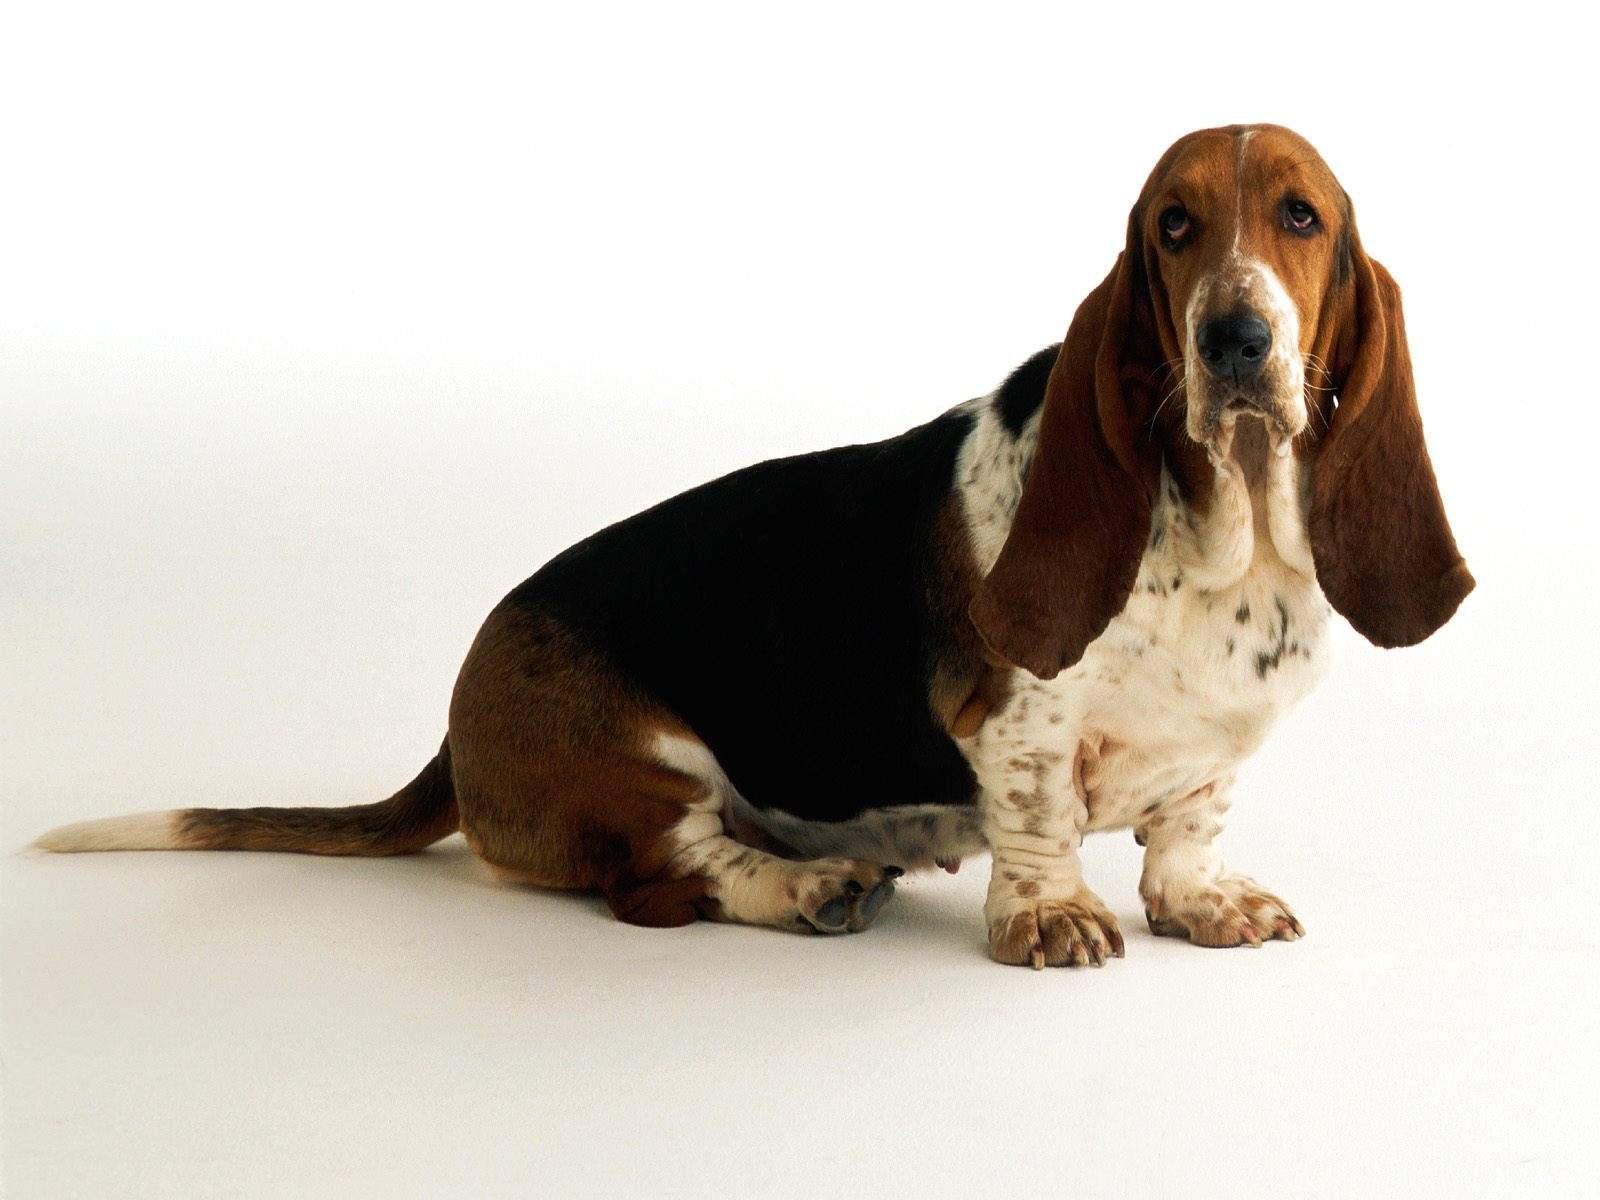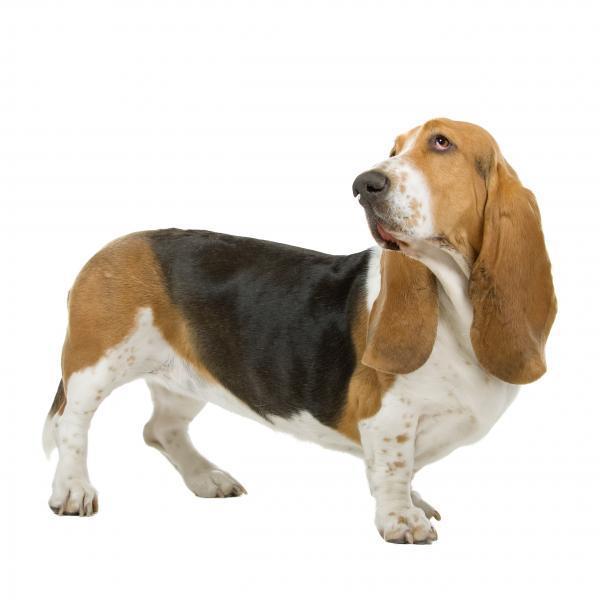The first image is the image on the left, the second image is the image on the right. Assess this claim about the two images: "The rear end of the dog in the image on the left is resting on the ground.". Correct or not? Answer yes or no. Yes. The first image is the image on the left, the second image is the image on the right. For the images shown, is this caption "Each image contains only one dog, and one image shows a basset hound standing in profile on a white background." true? Answer yes or no. Yes. 